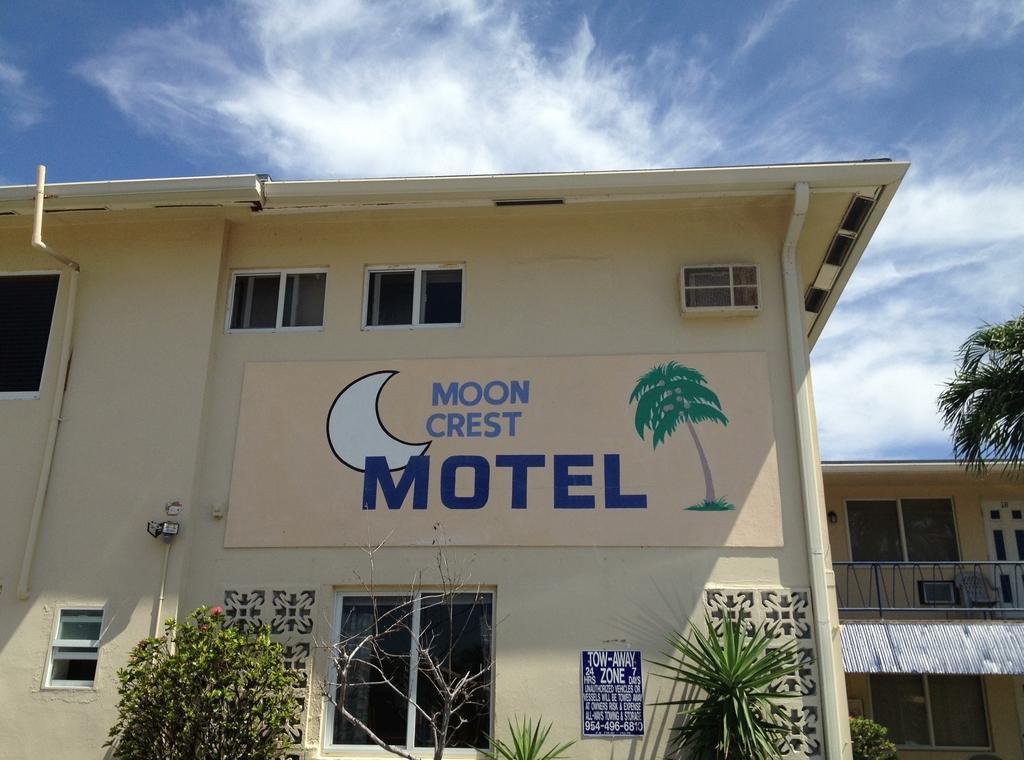How would you summarize this image in a sentence or two? In this image we can see a building with a poster and some text. There are plants. At the top of the image there is sky and clouds. 